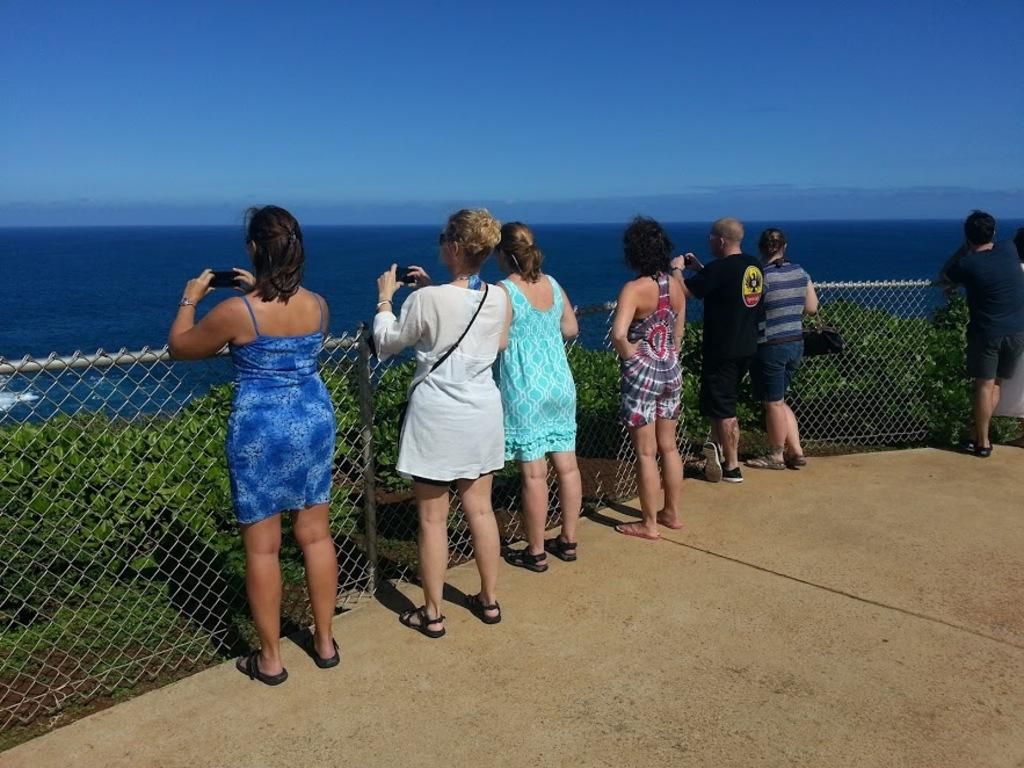What can be seen in the image? There are people standing in the image. Where are the people standing? The people are standing on the floor. What is in front of the people? There is a mesh in front of the people. What else is present in the image besides the people? There are plants in the image. What can be seen in the background of the image? There is water and the sky visible in the background of the image. What type of metal is being used to organize the plants in the image? There is no metal or organization of plants present in the image. 